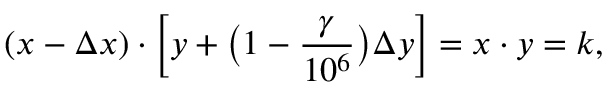Convert formula to latex. <formula><loc_0><loc_0><loc_500><loc_500>( x - \Delta x ) \cdot \left [ y + \left ( 1 - \frac { \gamma } { 1 0 ^ { 6 } } \right ) \Delta y \right ] = x \cdot y = k ,</formula> 